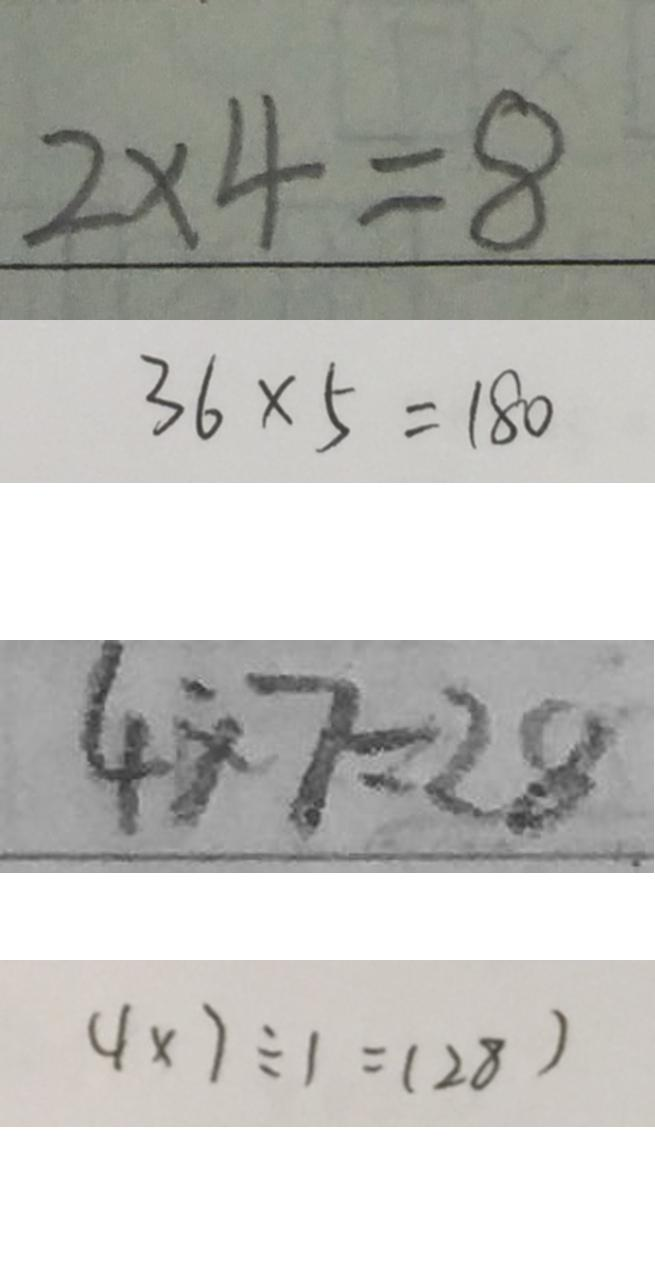Convert formula to latex. <formula><loc_0><loc_0><loc_500><loc_500>2 \times 4 = 8 
 3 6 \times 5 = 1 8 0 
 4 \times 7 = 2 8 
 4 \times 7 \div 1 = ( 2 8 )</formula> 